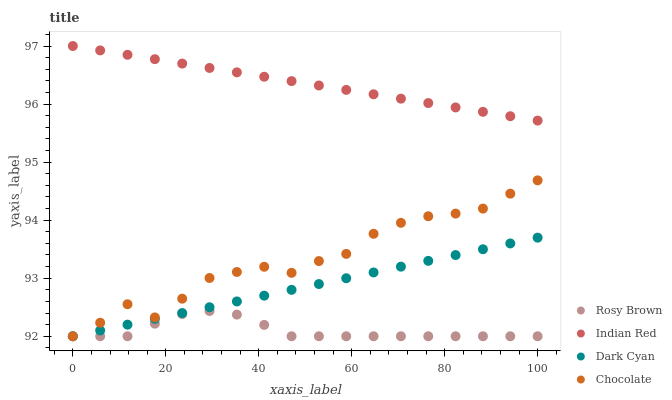Does Rosy Brown have the minimum area under the curve?
Answer yes or no. Yes. Does Indian Red have the maximum area under the curve?
Answer yes or no. Yes. Does Indian Red have the minimum area under the curve?
Answer yes or no. No. Does Rosy Brown have the maximum area under the curve?
Answer yes or no. No. Is Indian Red the smoothest?
Answer yes or no. Yes. Is Chocolate the roughest?
Answer yes or no. Yes. Is Rosy Brown the smoothest?
Answer yes or no. No. Is Rosy Brown the roughest?
Answer yes or no. No. Does Dark Cyan have the lowest value?
Answer yes or no. Yes. Does Indian Red have the lowest value?
Answer yes or no. No. Does Indian Red have the highest value?
Answer yes or no. Yes. Does Rosy Brown have the highest value?
Answer yes or no. No. Is Rosy Brown less than Indian Red?
Answer yes or no. Yes. Is Indian Red greater than Rosy Brown?
Answer yes or no. Yes. Does Dark Cyan intersect Chocolate?
Answer yes or no. Yes. Is Dark Cyan less than Chocolate?
Answer yes or no. No. Is Dark Cyan greater than Chocolate?
Answer yes or no. No. Does Rosy Brown intersect Indian Red?
Answer yes or no. No. 